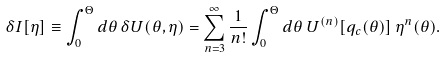Convert formula to latex. <formula><loc_0><loc_0><loc_500><loc_500>\delta I [ \eta ] \equiv \int _ { 0 } ^ { \Theta } d \theta \, \delta U ( \theta , \eta ) = \sum _ { n = 3 } ^ { \infty } \frac { 1 } { n ! } \int _ { 0 } ^ { \Theta } d \theta \, U ^ { ( n ) } [ q _ { c } ( \theta ) ] \, \eta ^ { n } ( \theta ) .</formula> 